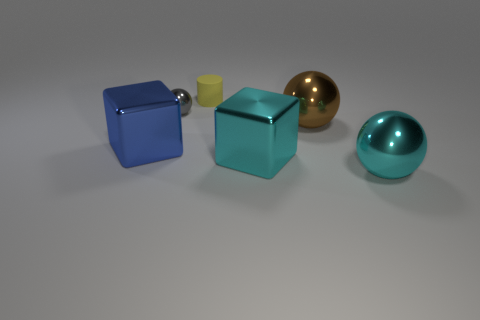What number of other objects are there of the same size as the gray metal sphere?
Your answer should be very brief. 1. Does the blue thing have the same material as the small gray ball that is behind the big blue shiny block?
Your answer should be compact. Yes. Are there the same number of brown objects to the left of the big blue shiny cube and big cyan metallic things in front of the big cyan metal cube?
Keep it short and to the point. No. What material is the blue thing?
Offer a very short reply. Metal. The rubber cylinder that is the same size as the gray thing is what color?
Offer a terse response. Yellow. There is a large shiny object on the right side of the large brown thing; is there a yellow matte cylinder right of it?
Offer a terse response. No. How many cylinders are either gray objects or blue things?
Give a very brief answer. 0. How big is the blue block left of the big sphere that is in front of the large shiny cube right of the yellow matte cylinder?
Your answer should be compact. Large. There is a cyan metal ball; are there any brown metallic balls right of it?
Keep it short and to the point. No. How many things are metallic balls right of the large brown metallic sphere or small gray objects?
Make the answer very short. 2. 